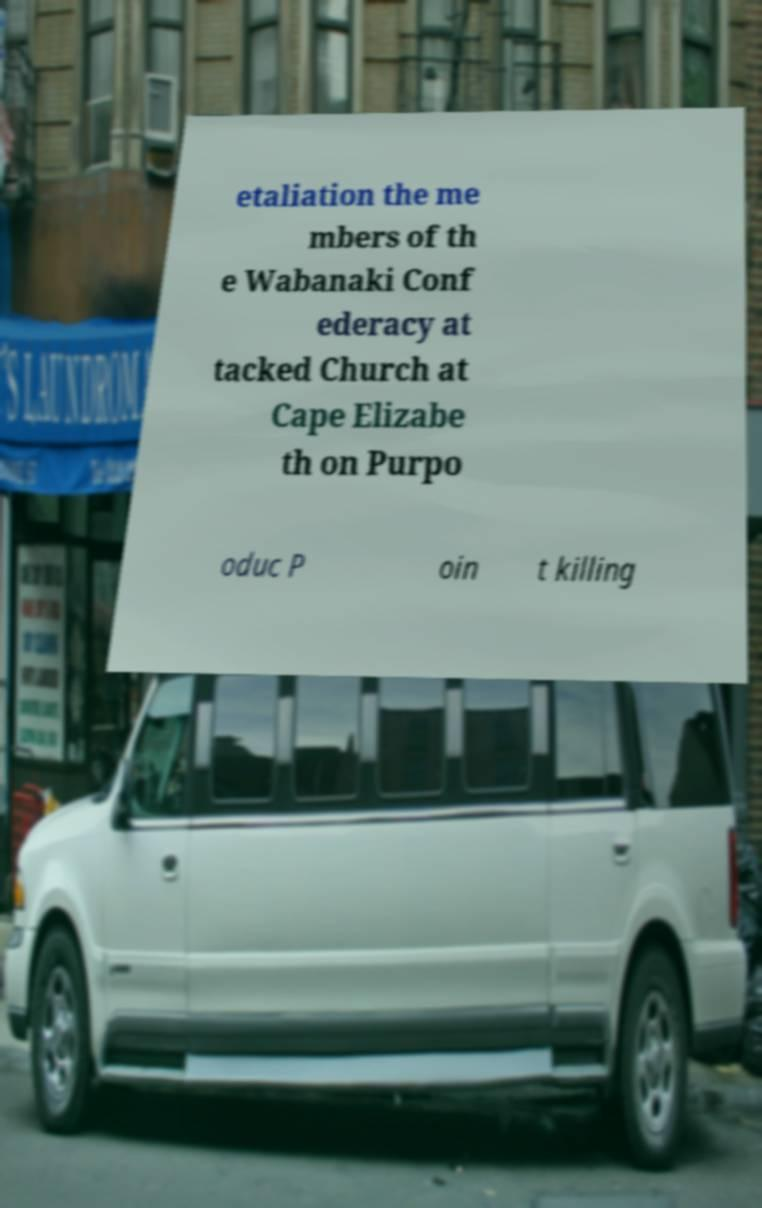What messages or text are displayed in this image? I need them in a readable, typed format. etaliation the me mbers of th e Wabanaki Conf ederacy at tacked Church at Cape Elizabe th on Purpo oduc P oin t killing 